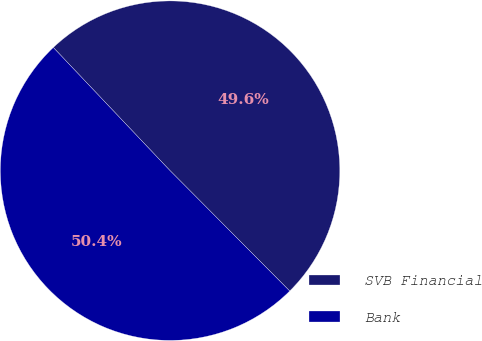<chart> <loc_0><loc_0><loc_500><loc_500><pie_chart><fcel>SVB Financial<fcel>Bank<nl><fcel>49.62%<fcel>50.38%<nl></chart> 